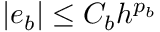<formula> <loc_0><loc_0><loc_500><loc_500>| e _ { b } | \leq C _ { b } h ^ { p _ { b } }</formula> 